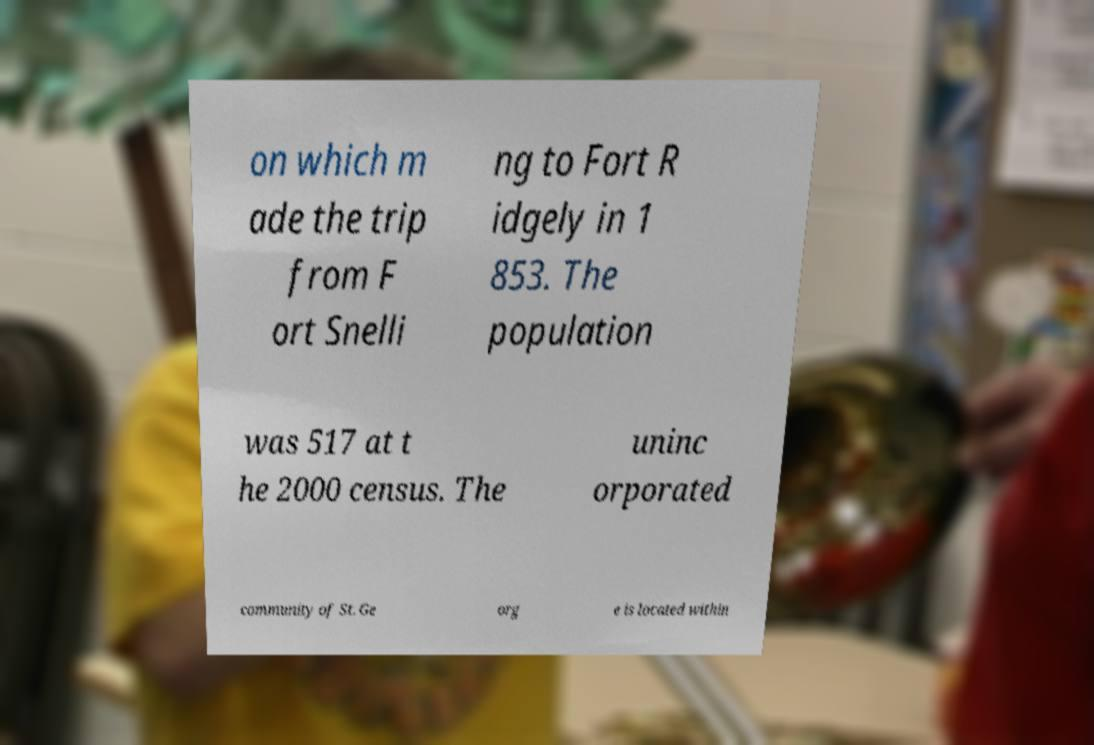For documentation purposes, I need the text within this image transcribed. Could you provide that? on which m ade the trip from F ort Snelli ng to Fort R idgely in 1 853. The population was 517 at t he 2000 census. The uninc orporated community of St. Ge org e is located within 